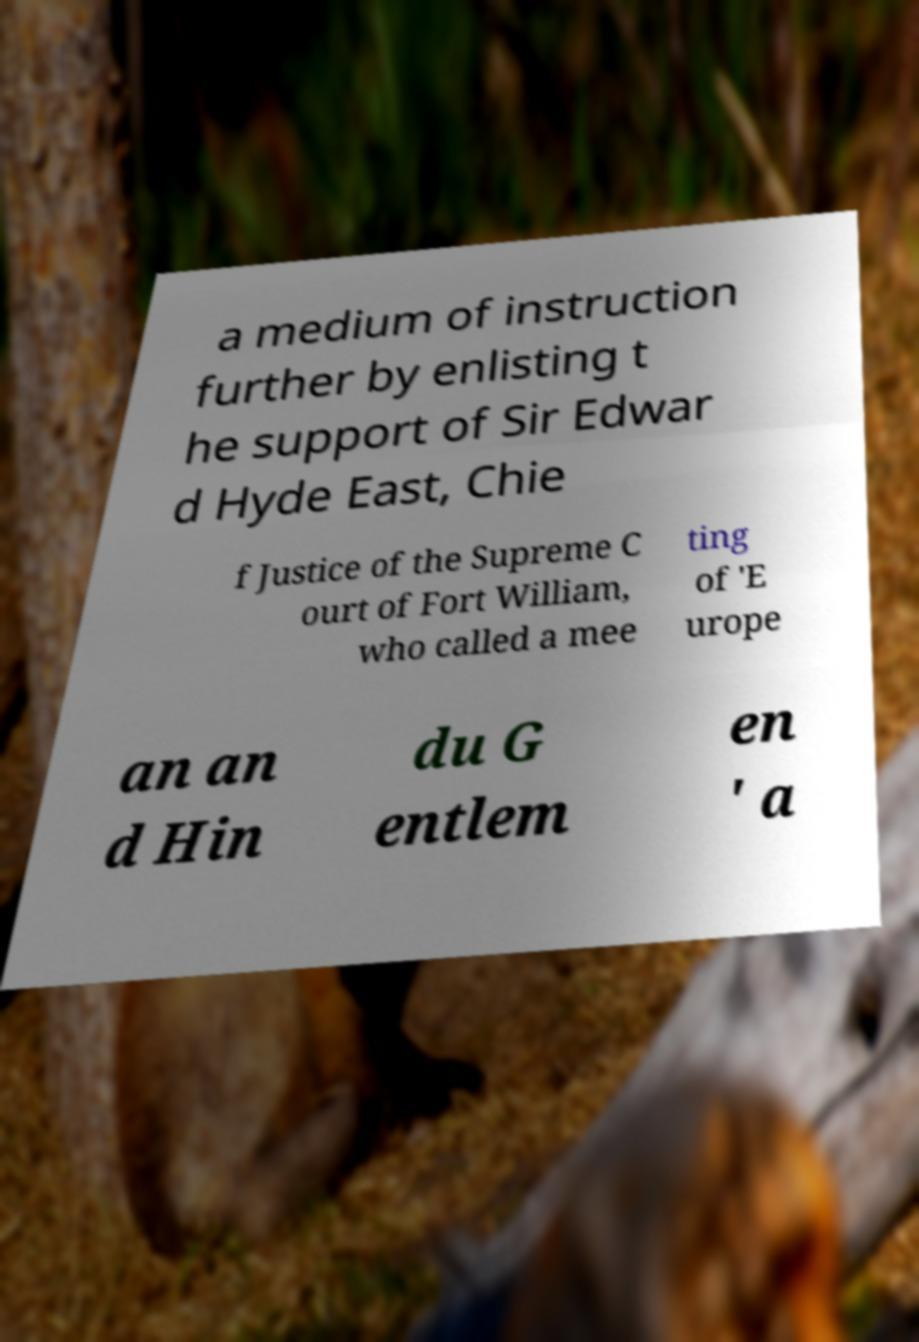Can you accurately transcribe the text from the provided image for me? a medium of instruction further by enlisting t he support of Sir Edwar d Hyde East, Chie f Justice of the Supreme C ourt of Fort William, who called a mee ting of 'E urope an an d Hin du G entlem en ' a 